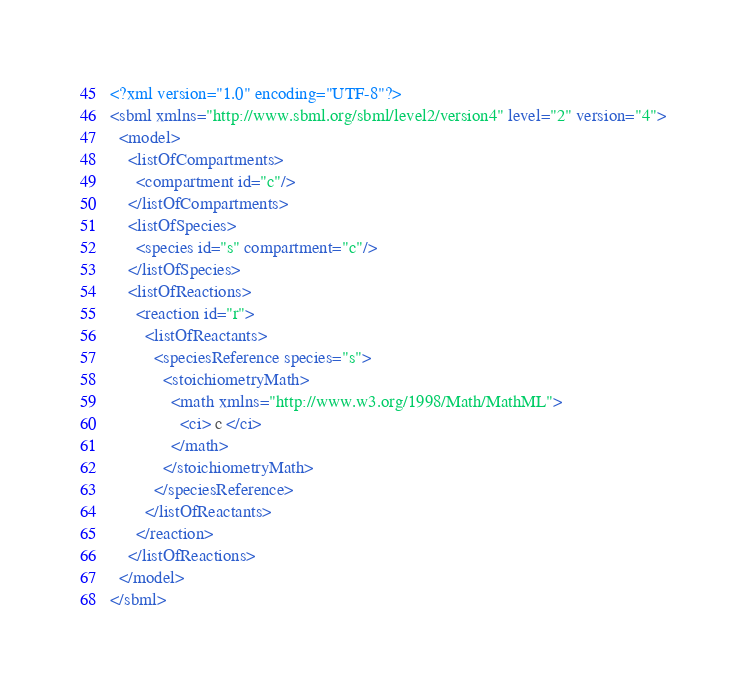Convert code to text. <code><loc_0><loc_0><loc_500><loc_500><_XML_><?xml version="1.0" encoding="UTF-8"?>
<sbml xmlns="http://www.sbml.org/sbml/level2/version4" level="2" version="4">
  <model>
    <listOfCompartments>
      <compartment id="c"/>
    </listOfCompartments>
    <listOfSpecies>
      <species id="s" compartment="c"/>
    </listOfSpecies>
    <listOfReactions>
      <reaction id="r">
        <listOfReactants>
          <speciesReference species="s">
            <stoichiometryMath>
              <math xmlns="http://www.w3.org/1998/Math/MathML">
                <ci> c </ci>
              </math>
            </stoichiometryMath>
          </speciesReference>
        </listOfReactants>
      </reaction>
    </listOfReactions>
  </model>
</sbml>
</code> 